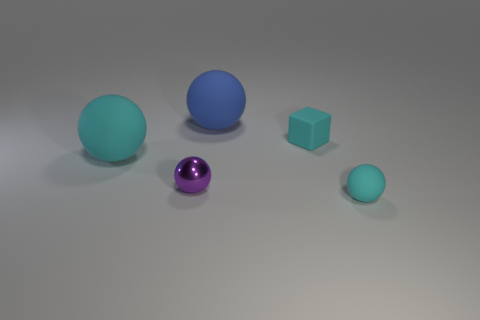How many other objects are there of the same color as the rubber cube?
Your response must be concise. 2. Does the matte block have the same color as the small ball left of the blue rubber object?
Keep it short and to the point. No. Is the shape of the large cyan thing the same as the cyan rubber thing that is to the right of the cyan rubber cube?
Offer a terse response. Yes. The tiny object in front of the tiny shiny thing has what shape?
Your response must be concise. Sphere. Is the shape of the big blue thing the same as the small purple thing?
Provide a succinct answer. Yes. There is another metallic object that is the same shape as the big blue thing; what is its size?
Your response must be concise. Small. Is the size of the cyan matte sphere on the right side of the purple sphere the same as the blue rubber thing?
Make the answer very short. No. How big is the rubber ball that is both in front of the big blue rubber thing and to the left of the small cyan sphere?
Make the answer very short. Large. There is a tiny sphere that is the same color as the small block; what is its material?
Ensure brevity in your answer.  Rubber. What number of tiny metal balls are the same color as the rubber cube?
Offer a very short reply. 0. 